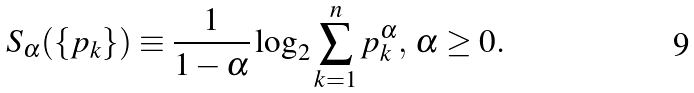<formula> <loc_0><loc_0><loc_500><loc_500>S _ { \alpha } ( \{ p _ { k } \} ) \equiv \frac { 1 } { 1 - \alpha } \log _ { 2 } \sum _ { k = 1 } ^ { n } p _ { k } ^ { \alpha } , \, \alpha \geq 0 .</formula> 